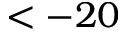<formula> <loc_0><loc_0><loc_500><loc_500>< - 2 0</formula> 